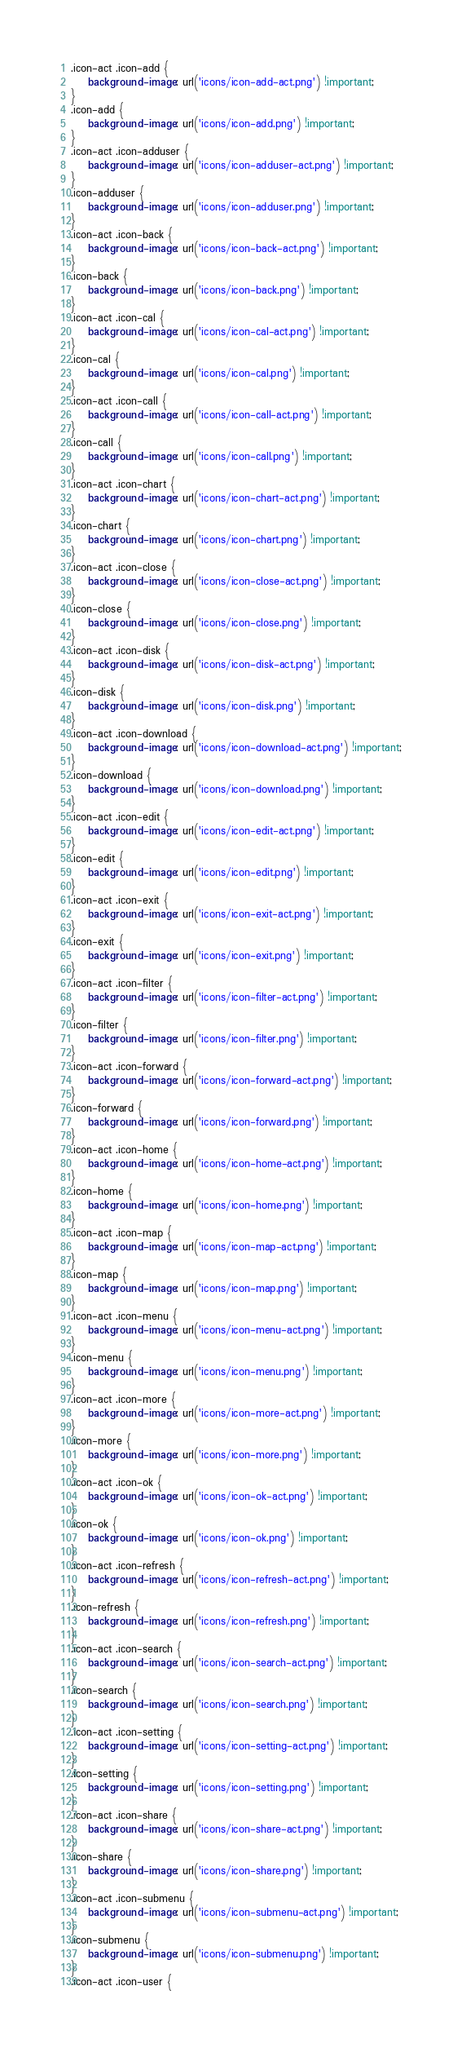<code> <loc_0><loc_0><loc_500><loc_500><_CSS_>.icon-act .icon-add {
    background-image: url('icons/icon-add-act.png') !important;
}
.icon-add {
    background-image: url('icons/icon-add.png') !important;
}
.icon-act .icon-adduser {
    background-image: url('icons/icon-adduser-act.png') !important;
}
.icon-adduser {
    background-image: url('icons/icon-adduser.png') !important;
}
.icon-act .icon-back {
    background-image: url('icons/icon-back-act.png') !important;
}
.icon-back {
    background-image: url('icons/icon-back.png') !important;
}
.icon-act .icon-cal {
    background-image: url('icons/icon-cal-act.png') !important;
}
.icon-cal {
    background-image: url('icons/icon-cal.png') !important;
}
.icon-act .icon-call {
    background-image: url('icons/icon-call-act.png') !important;
}
.icon-call {
    background-image: url('icons/icon-call.png') !important;
}
.icon-act .icon-chart {
    background-image: url('icons/icon-chart-act.png') !important;
}
.icon-chart {
    background-image: url('icons/icon-chart.png') !important;
}
.icon-act .icon-close {
    background-image: url('icons/icon-close-act.png') !important;
}
.icon-close {
    background-image: url('icons/icon-close.png') !important;
}
.icon-act .icon-disk {
    background-image: url('icons/icon-disk-act.png') !important;
}
.icon-disk {
    background-image: url('icons/icon-disk.png') !important;
}
.icon-act .icon-download {
    background-image: url('icons/icon-download-act.png') !important;
}
.icon-download {
    background-image: url('icons/icon-download.png') !important;
}
.icon-act .icon-edit {
    background-image: url('icons/icon-edit-act.png') !important;
}
.icon-edit {
    background-image: url('icons/icon-edit.png') !important;
}
.icon-act .icon-exit {
    background-image: url('icons/icon-exit-act.png') !important;
}
.icon-exit {
    background-image: url('icons/icon-exit.png') !important;
}
.icon-act .icon-filter {
    background-image: url('icons/icon-filter-act.png') !important;
}
.icon-filter {
    background-image: url('icons/icon-filter.png') !important;
}
.icon-act .icon-forward {
    background-image: url('icons/icon-forward-act.png') !important;
}
.icon-forward {
    background-image: url('icons/icon-forward.png') !important;
}
.icon-act .icon-home {
    background-image: url('icons/icon-home-act.png') !important;
}
.icon-home {
    background-image: url('icons/icon-home.png') !important;
}
.icon-act .icon-map {
    background-image: url('icons/icon-map-act.png') !important;
}
.icon-map {
    background-image: url('icons/icon-map.png') !important;
}
.icon-act .icon-menu {
    background-image: url('icons/icon-menu-act.png') !important;
}
.icon-menu {
    background-image: url('icons/icon-menu.png') !important;
}
.icon-act .icon-more {
    background-image: url('icons/icon-more-act.png') !important;
}
.icon-more {
    background-image: url('icons/icon-more.png') !important;
}
.icon-act .icon-ok {
    background-image: url('icons/icon-ok-act.png') !important;
}
.icon-ok {
    background-image: url('icons/icon-ok.png') !important;
}
.icon-act .icon-refresh {
    background-image: url('icons/icon-refresh-act.png') !important;
}
.icon-refresh {
    background-image: url('icons/icon-refresh.png') !important;
}
.icon-act .icon-search {
    background-image: url('icons/icon-search-act.png') !important;
}
.icon-search {
    background-image: url('icons/icon-search.png') !important;
}
.icon-act .icon-setting {
    background-image: url('icons/icon-setting-act.png') !important;
}
.icon-setting {
    background-image: url('icons/icon-setting.png') !important;
}
.icon-act .icon-share {
    background-image: url('icons/icon-share-act.png') !important;
}
.icon-share {
    background-image: url('icons/icon-share.png') !important;
}
.icon-act .icon-submenu {
    background-image: url('icons/icon-submenu-act.png') !important;
}
.icon-submenu {
    background-image: url('icons/icon-submenu.png') !important;
}
.icon-act .icon-user {</code> 